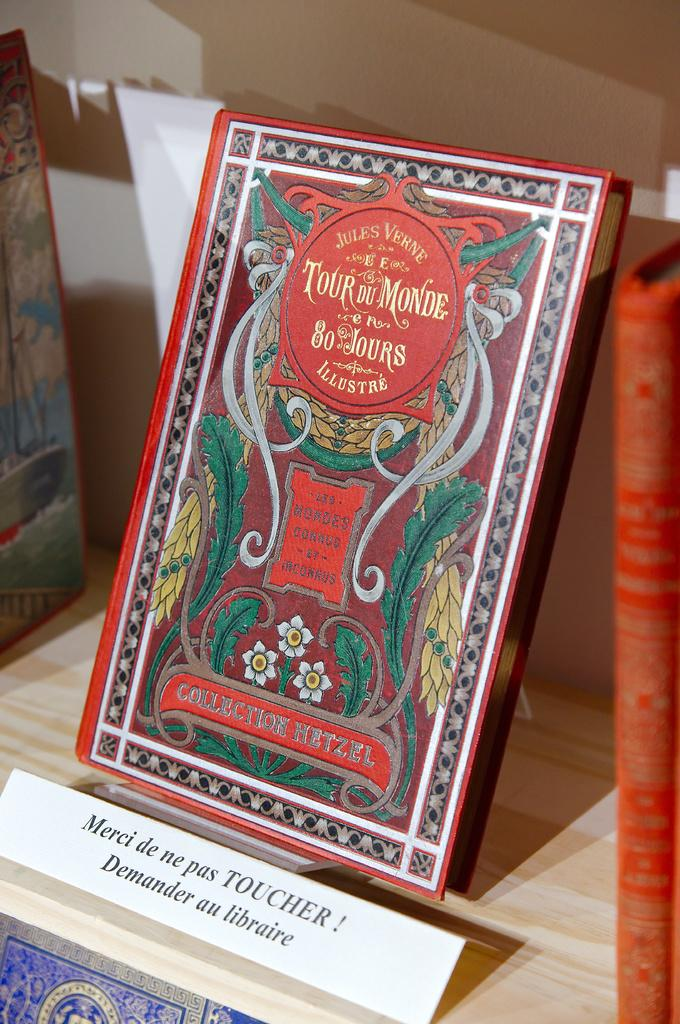<image>
Write a terse but informative summary of the picture. A book displayed saying Tour Du Monde sitting by another book. 